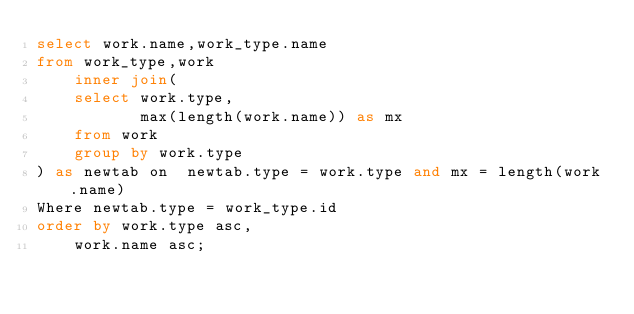<code> <loc_0><loc_0><loc_500><loc_500><_SQL_>select work.name,work_type.name
from work_type,work 
	inner join(
	select work.type,
	       max(length(work.name)) as mx
	from work
	group by work.type
) as newtab on  newtab.type = work.type and mx = length(work.name)
Where newtab.type = work_type.id
order by work.type asc,
	work.name asc;
</code> 